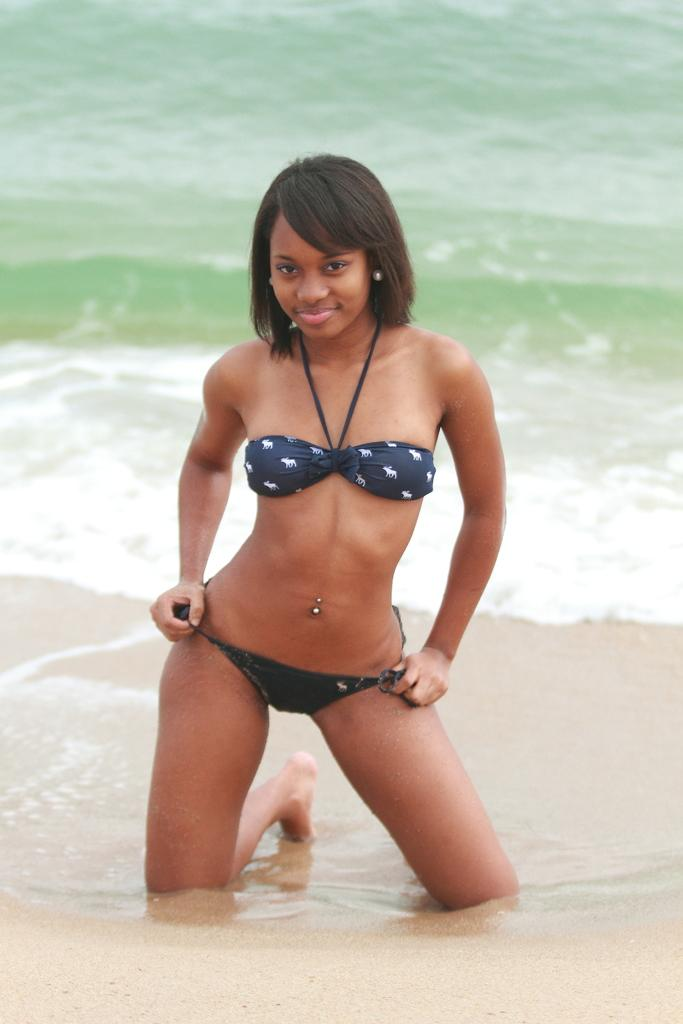Who is present in the image? There is a girl in the image. Where is the girl located? The girl is at the sea shore. What type of dirt can be seen on the girl's shoes in the image? There is no dirt visible on the girl's shoes in the image, as the facts provided do not mention any dirt. 